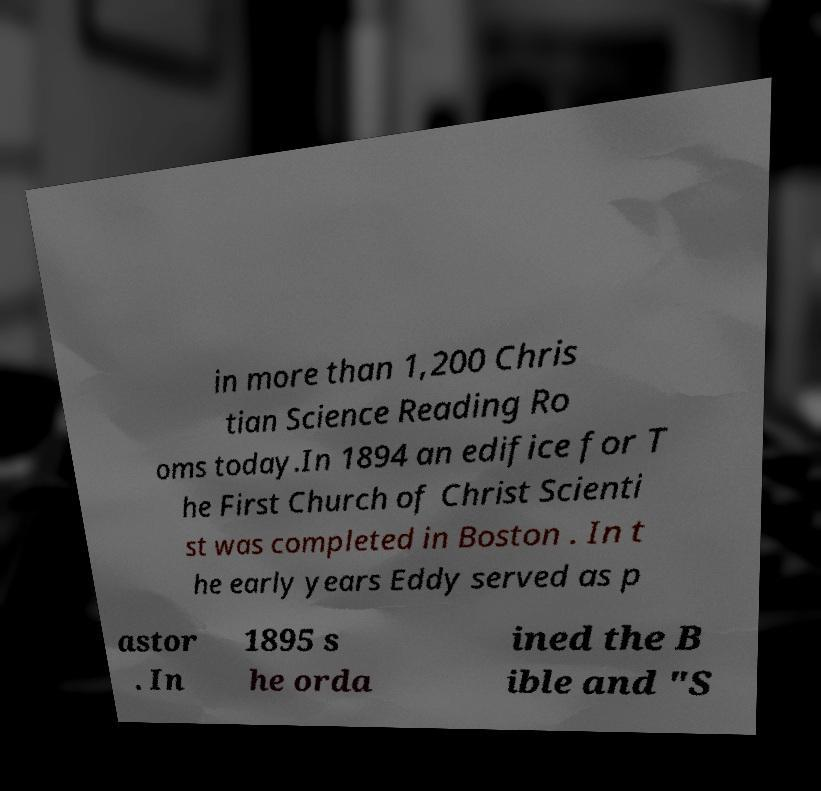Can you read and provide the text displayed in the image?This photo seems to have some interesting text. Can you extract and type it out for me? in more than 1,200 Chris tian Science Reading Ro oms today.In 1894 an edifice for T he First Church of Christ Scienti st was completed in Boston . In t he early years Eddy served as p astor . In 1895 s he orda ined the B ible and "S 